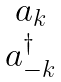Convert formula to latex. <formula><loc_0><loc_0><loc_500><loc_500>\begin{matrix} a _ { k } \\ a ^ { \dagger } _ { - k } \end{matrix}</formula> 